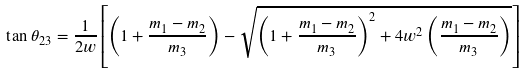Convert formula to latex. <formula><loc_0><loc_0><loc_500><loc_500>\tan \theta _ { 2 3 } = \frac { 1 } { 2 w } \left [ \left ( 1 + \frac { m _ { 1 } - m _ { 2 } } { m _ { 3 } } \right ) - \sqrt { \left ( 1 + \frac { m _ { 1 } - m _ { 2 } } { m _ { 3 } } \right ) ^ { 2 } + 4 w ^ { 2 } \left ( \frac { m _ { 1 } - m _ { 2 } } { m _ { 3 } } \right ) } \right ]</formula> 